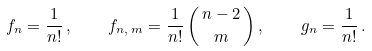<formula> <loc_0><loc_0><loc_500><loc_500>f _ { n } = \frac { 1 } { n ! } \, , \quad f _ { n , \, m } = \frac { 1 } { n ! } \, { \, n - 2 \, \choose m } \, , \quad g _ { n } = \frac { 1 } { n ! } \, .</formula> 